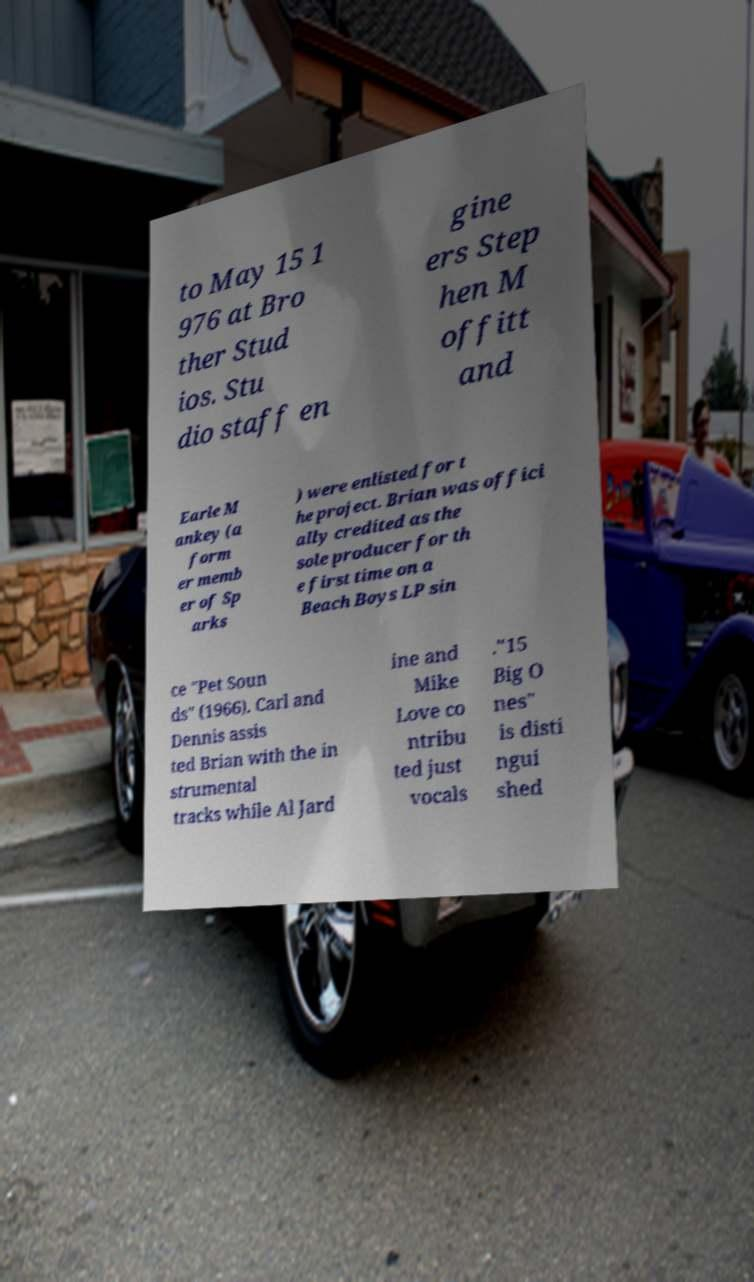Could you assist in decoding the text presented in this image and type it out clearly? to May 15 1 976 at Bro ther Stud ios. Stu dio staff en gine ers Step hen M offitt and Earle M ankey (a form er memb er of Sp arks ) were enlisted for t he project. Brian was offici ally credited as the sole producer for th e first time on a Beach Boys LP sin ce "Pet Soun ds" (1966). Carl and Dennis assis ted Brian with the in strumental tracks while Al Jard ine and Mike Love co ntribu ted just vocals ."15 Big O nes" is disti ngui shed 